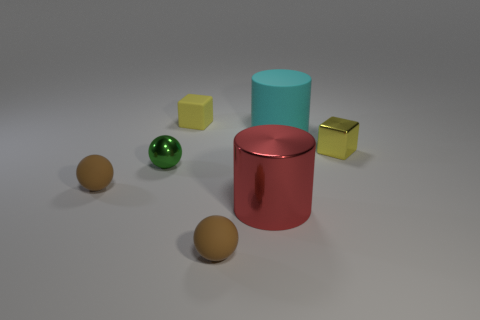There is a small yellow metallic thing; is its shape the same as the tiny brown object on the left side of the tiny yellow rubber block?
Keep it short and to the point. No. Are there fewer large cylinders right of the big red cylinder than gray cylinders?
Make the answer very short. No. Are there any small rubber blocks on the left side of the small green sphere?
Keep it short and to the point. No. Is there a small yellow object that has the same shape as the large red object?
Your answer should be compact. No. There is a thing that is the same size as the red cylinder; what is its shape?
Your answer should be compact. Cylinder. How many things are big things in front of the metallic ball or green metallic objects?
Your response must be concise. 2. Does the matte cylinder have the same color as the large metal thing?
Offer a terse response. No. There is a thing in front of the large red cylinder; what is its size?
Offer a very short reply. Small. Is there a metal block that has the same size as the metal cylinder?
Your answer should be compact. No. Do the brown object on the right side of the yellow rubber cube and the shiny cylinder have the same size?
Ensure brevity in your answer.  No. 